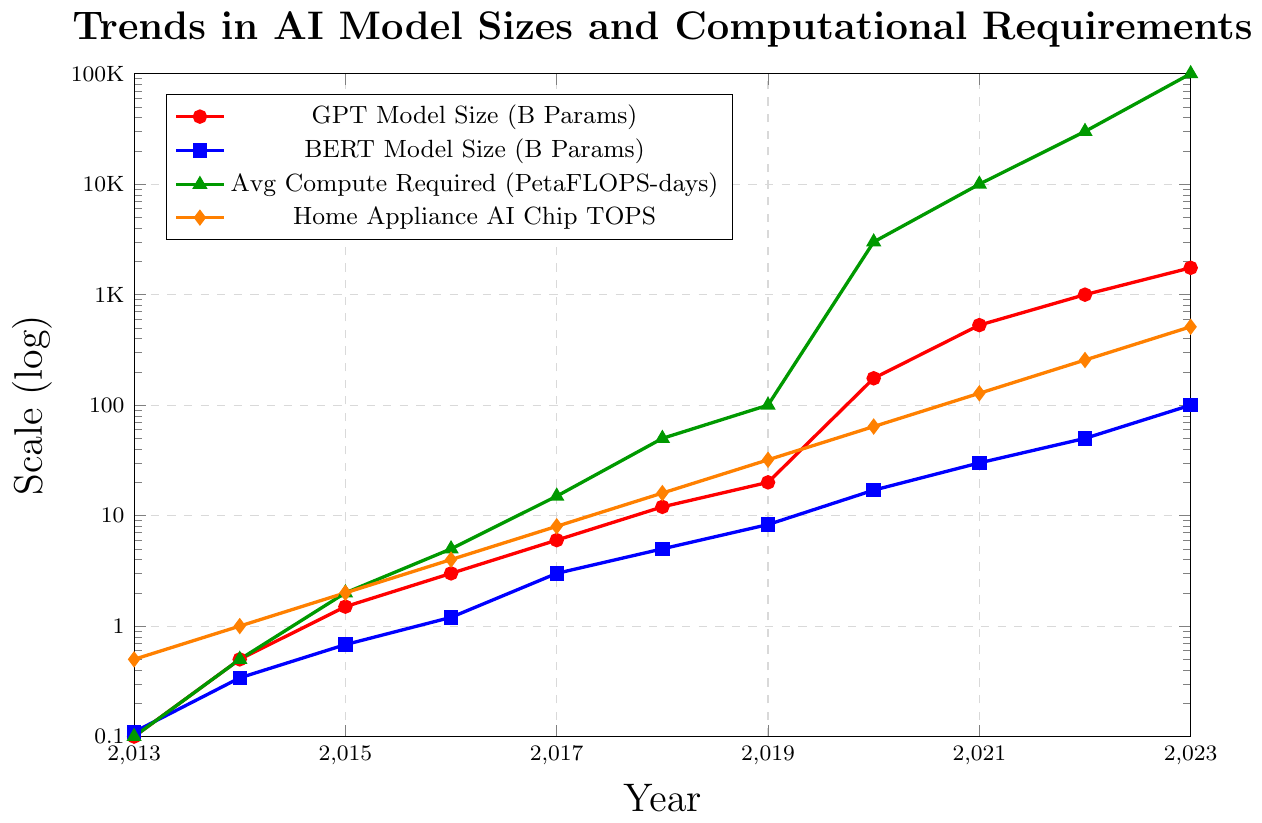How has the GPT Model size changed from 2013 to 2023? To find the change in the GPT Model size from 2013 to 2023, look at the red line representing GPT Model Size in the figure. The size in 2013 is 0.1 billion parameters and in 2023 it is 1750 billion parameters.
Answer: It increased by 1749.9 billion parameters Between which years did the BERT Model size see the highest growth? To determine the highest growth period for the BERT Model size, observe the blue markers in the graph. The biggest jump appears between 2019 (8.3 billion) and 2020 (17 billion).
Answer: 2019 to 2020 Is the computational requirement trend line below the Home Appliance AI Chip trend line at any point? Compare the green and orange lines on the graph. The green line (computational requirements) starts below the orange line (Home Appliance AI Chip TOPS) until it surpasses it around 2019 and remains above it thereafter.
Answer: Yes, before 2019 What is the average increase per year in Home Appliance AI Chip TOPS from 2018 to 2023? Calculate the difference between the values in 2023 (512) and 2018 (16), then divide by the number of years (2023-2018 = 5). This gives (512-16)/5 = 496/5 = 99.2.
Answer: 99.2 TOPS per year Which model's size grew faster from 2020 to 2023, GPT or BERT? Look at the growth of the red and blue lines from 2020 to 2023. GPT increased from 175 to 1750 billion (1750-175 = 1575 billion), while BERT increased from 17 to 100 billion (100-17 = 83 billion).
Answer: GPT In 2023, how many times larger is the average compute required than the Home Appliance AI Chip TOPS? The average compute required in 2023 is 100000 PetaFLOPS-days and Home Appliance AI Chip TOPS is 512. So, 100000 / 512 ≈ 195.31 times larger.
Answer: Approximately 195.31 times Compare the trends of computational requirements and Home Appliance AI Chip TOPS. Which grows faster? Observe the slopes of the green and orange lines throughout the years. The green line shows a more rapid upward trend, especially after 2018, indicating computational requirements grow faster compared to Home Appliance AI Chip TOPS.
Answer: Computational requirements grow faster What was the BERT Model size in 2017 and how does it compare to the GPT Model size at the same time? In 2017, the BERT Model size (blue marker) is 3 billion parameters, while the GPT Model size (red marker) is 6 billion parameters. The GPT Model size is double that of BERT for this year.
Answer: GPT Model size is double By how much did the average compute required increase from 2015 to 2020? The average compute required in 2015 is 2 PetaFLOPS-days, and in 2020 it is 3000 PetaFLOPS-days. Thus the increase is 3000-2 = 2998 PetaFLOPS-days.
Answer: 2998 PetaFLOPS-days When did the GPT Model size first exceed 1000 billion parameters? Look at the red line indicating GPT Model Size; it first crosses 1000 billion parameters between 2021 and 2022.
Answer: 2022 